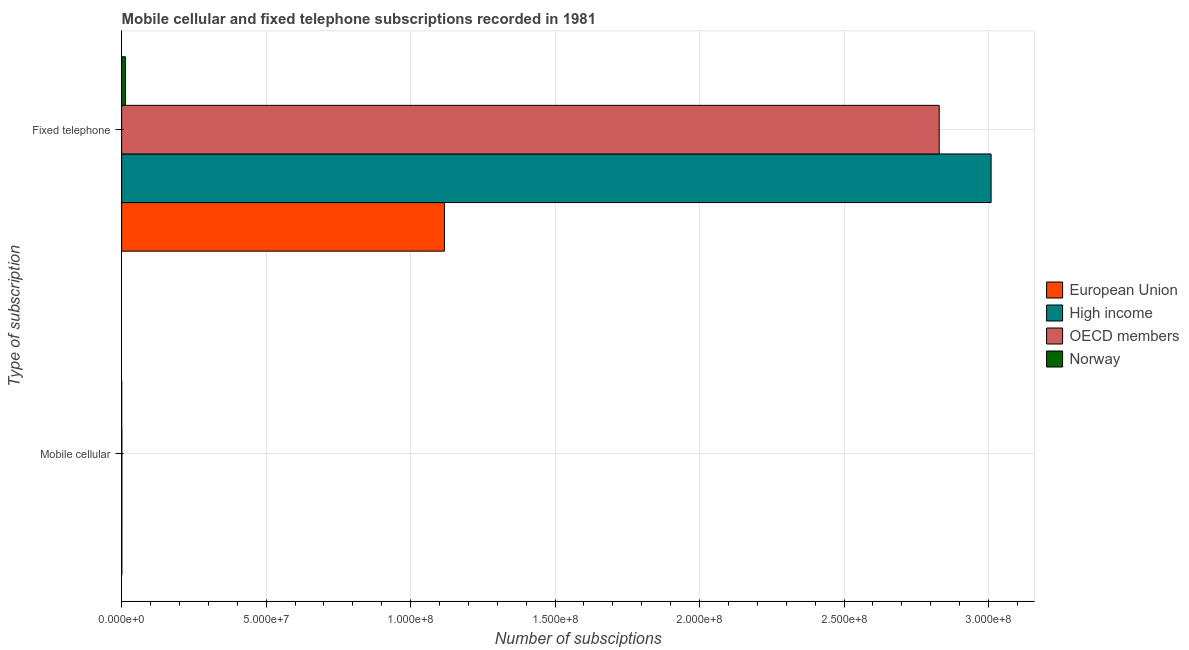How many different coloured bars are there?
Give a very brief answer. 4. What is the label of the 2nd group of bars from the top?
Ensure brevity in your answer.  Mobile cellular. What is the number of fixed telephone subscriptions in Norway?
Provide a short and direct response. 1.30e+06. Across all countries, what is the maximum number of fixed telephone subscriptions?
Provide a short and direct response. 3.01e+08. Across all countries, what is the minimum number of fixed telephone subscriptions?
Your answer should be very brief. 1.30e+06. What is the total number of mobile cellular subscriptions in the graph?
Your answer should be compact. 1.77e+05. What is the difference between the number of fixed telephone subscriptions in Norway and that in OECD members?
Provide a succinct answer. -2.82e+08. What is the difference between the number of fixed telephone subscriptions in European Union and the number of mobile cellular subscriptions in High income?
Provide a short and direct response. 1.12e+08. What is the average number of fixed telephone subscriptions per country?
Give a very brief answer. 1.74e+08. What is the difference between the number of mobile cellular subscriptions and number of fixed telephone subscriptions in Norway?
Offer a terse response. -1.30e+06. What is the ratio of the number of fixed telephone subscriptions in OECD members to that in European Union?
Keep it short and to the point. 2.53. In how many countries, is the number of fixed telephone subscriptions greater than the average number of fixed telephone subscriptions taken over all countries?
Offer a terse response. 2. What does the 2nd bar from the top in Fixed telephone represents?
Provide a succinct answer. OECD members. How many bars are there?
Offer a very short reply. 8. Are the values on the major ticks of X-axis written in scientific E-notation?
Offer a very short reply. Yes. Does the graph contain any zero values?
Provide a succinct answer. No. Does the graph contain grids?
Ensure brevity in your answer.  Yes. Where does the legend appear in the graph?
Offer a terse response. Center right. What is the title of the graph?
Offer a very short reply. Mobile cellular and fixed telephone subscriptions recorded in 1981. Does "China" appear as one of the legend labels in the graph?
Your response must be concise. No. What is the label or title of the X-axis?
Keep it short and to the point. Number of subsciptions. What is the label or title of the Y-axis?
Your answer should be compact. Type of subscription. What is the Number of subsciptions in European Union in Mobile cellular?
Offer a terse response. 4.86e+04. What is the Number of subsciptions of High income in Mobile cellular?
Offer a very short reply. 6.36e+04. What is the Number of subsciptions of OECD members in Mobile cellular?
Give a very brief answer. 6.36e+04. What is the Number of subsciptions in Norway in Mobile cellular?
Offer a terse response. 1670. What is the Number of subsciptions in European Union in Fixed telephone?
Provide a short and direct response. 1.12e+08. What is the Number of subsciptions in High income in Fixed telephone?
Your answer should be compact. 3.01e+08. What is the Number of subsciptions in OECD members in Fixed telephone?
Ensure brevity in your answer.  2.83e+08. What is the Number of subsciptions in Norway in Fixed telephone?
Your answer should be compact. 1.30e+06. Across all Type of subscription, what is the maximum Number of subsciptions of European Union?
Your response must be concise. 1.12e+08. Across all Type of subscription, what is the maximum Number of subsciptions in High income?
Keep it short and to the point. 3.01e+08. Across all Type of subscription, what is the maximum Number of subsciptions of OECD members?
Offer a terse response. 2.83e+08. Across all Type of subscription, what is the maximum Number of subsciptions of Norway?
Your answer should be very brief. 1.30e+06. Across all Type of subscription, what is the minimum Number of subsciptions in European Union?
Your answer should be compact. 4.86e+04. Across all Type of subscription, what is the minimum Number of subsciptions of High income?
Your response must be concise. 6.36e+04. Across all Type of subscription, what is the minimum Number of subsciptions in OECD members?
Your answer should be very brief. 6.36e+04. Across all Type of subscription, what is the minimum Number of subsciptions in Norway?
Your response must be concise. 1670. What is the total Number of subsciptions of European Union in the graph?
Provide a succinct answer. 1.12e+08. What is the total Number of subsciptions of High income in the graph?
Your answer should be very brief. 3.01e+08. What is the total Number of subsciptions of OECD members in the graph?
Give a very brief answer. 2.83e+08. What is the total Number of subsciptions in Norway in the graph?
Keep it short and to the point. 1.30e+06. What is the difference between the Number of subsciptions in European Union in Mobile cellular and that in Fixed telephone?
Offer a terse response. -1.12e+08. What is the difference between the Number of subsciptions in High income in Mobile cellular and that in Fixed telephone?
Keep it short and to the point. -3.01e+08. What is the difference between the Number of subsciptions of OECD members in Mobile cellular and that in Fixed telephone?
Provide a succinct answer. -2.83e+08. What is the difference between the Number of subsciptions of Norway in Mobile cellular and that in Fixed telephone?
Give a very brief answer. -1.30e+06. What is the difference between the Number of subsciptions of European Union in Mobile cellular and the Number of subsciptions of High income in Fixed telephone?
Provide a succinct answer. -3.01e+08. What is the difference between the Number of subsciptions of European Union in Mobile cellular and the Number of subsciptions of OECD members in Fixed telephone?
Your answer should be compact. -2.83e+08. What is the difference between the Number of subsciptions in European Union in Mobile cellular and the Number of subsciptions in Norway in Fixed telephone?
Your answer should be very brief. -1.25e+06. What is the difference between the Number of subsciptions in High income in Mobile cellular and the Number of subsciptions in OECD members in Fixed telephone?
Make the answer very short. -2.83e+08. What is the difference between the Number of subsciptions of High income in Mobile cellular and the Number of subsciptions of Norway in Fixed telephone?
Your answer should be very brief. -1.23e+06. What is the difference between the Number of subsciptions in OECD members in Mobile cellular and the Number of subsciptions in Norway in Fixed telephone?
Provide a succinct answer. -1.23e+06. What is the average Number of subsciptions of European Union per Type of subscription?
Ensure brevity in your answer.  5.59e+07. What is the average Number of subsciptions of High income per Type of subscription?
Your response must be concise. 1.50e+08. What is the average Number of subsciptions in OECD members per Type of subscription?
Ensure brevity in your answer.  1.42e+08. What is the average Number of subsciptions in Norway per Type of subscription?
Provide a short and direct response. 6.50e+05. What is the difference between the Number of subsciptions in European Union and Number of subsciptions in High income in Mobile cellular?
Provide a succinct answer. -1.49e+04. What is the difference between the Number of subsciptions of European Union and Number of subsciptions of OECD members in Mobile cellular?
Give a very brief answer. -1.49e+04. What is the difference between the Number of subsciptions of European Union and Number of subsciptions of Norway in Mobile cellular?
Provide a short and direct response. 4.70e+04. What is the difference between the Number of subsciptions of High income and Number of subsciptions of OECD members in Mobile cellular?
Keep it short and to the point. 0. What is the difference between the Number of subsciptions of High income and Number of subsciptions of Norway in Mobile cellular?
Offer a terse response. 6.19e+04. What is the difference between the Number of subsciptions in OECD members and Number of subsciptions in Norway in Mobile cellular?
Provide a succinct answer. 6.19e+04. What is the difference between the Number of subsciptions of European Union and Number of subsciptions of High income in Fixed telephone?
Your answer should be compact. -1.89e+08. What is the difference between the Number of subsciptions of European Union and Number of subsciptions of OECD members in Fixed telephone?
Keep it short and to the point. -1.71e+08. What is the difference between the Number of subsciptions in European Union and Number of subsciptions in Norway in Fixed telephone?
Your response must be concise. 1.10e+08. What is the difference between the Number of subsciptions in High income and Number of subsciptions in OECD members in Fixed telephone?
Your answer should be compact. 1.80e+07. What is the difference between the Number of subsciptions of High income and Number of subsciptions of Norway in Fixed telephone?
Keep it short and to the point. 3.00e+08. What is the difference between the Number of subsciptions of OECD members and Number of subsciptions of Norway in Fixed telephone?
Your response must be concise. 2.82e+08. What is the ratio of the Number of subsciptions of Norway in Mobile cellular to that in Fixed telephone?
Provide a short and direct response. 0. What is the difference between the highest and the second highest Number of subsciptions of European Union?
Offer a terse response. 1.12e+08. What is the difference between the highest and the second highest Number of subsciptions in High income?
Give a very brief answer. 3.01e+08. What is the difference between the highest and the second highest Number of subsciptions in OECD members?
Offer a terse response. 2.83e+08. What is the difference between the highest and the second highest Number of subsciptions of Norway?
Offer a very short reply. 1.30e+06. What is the difference between the highest and the lowest Number of subsciptions of European Union?
Your response must be concise. 1.12e+08. What is the difference between the highest and the lowest Number of subsciptions in High income?
Make the answer very short. 3.01e+08. What is the difference between the highest and the lowest Number of subsciptions in OECD members?
Offer a very short reply. 2.83e+08. What is the difference between the highest and the lowest Number of subsciptions of Norway?
Offer a very short reply. 1.30e+06. 